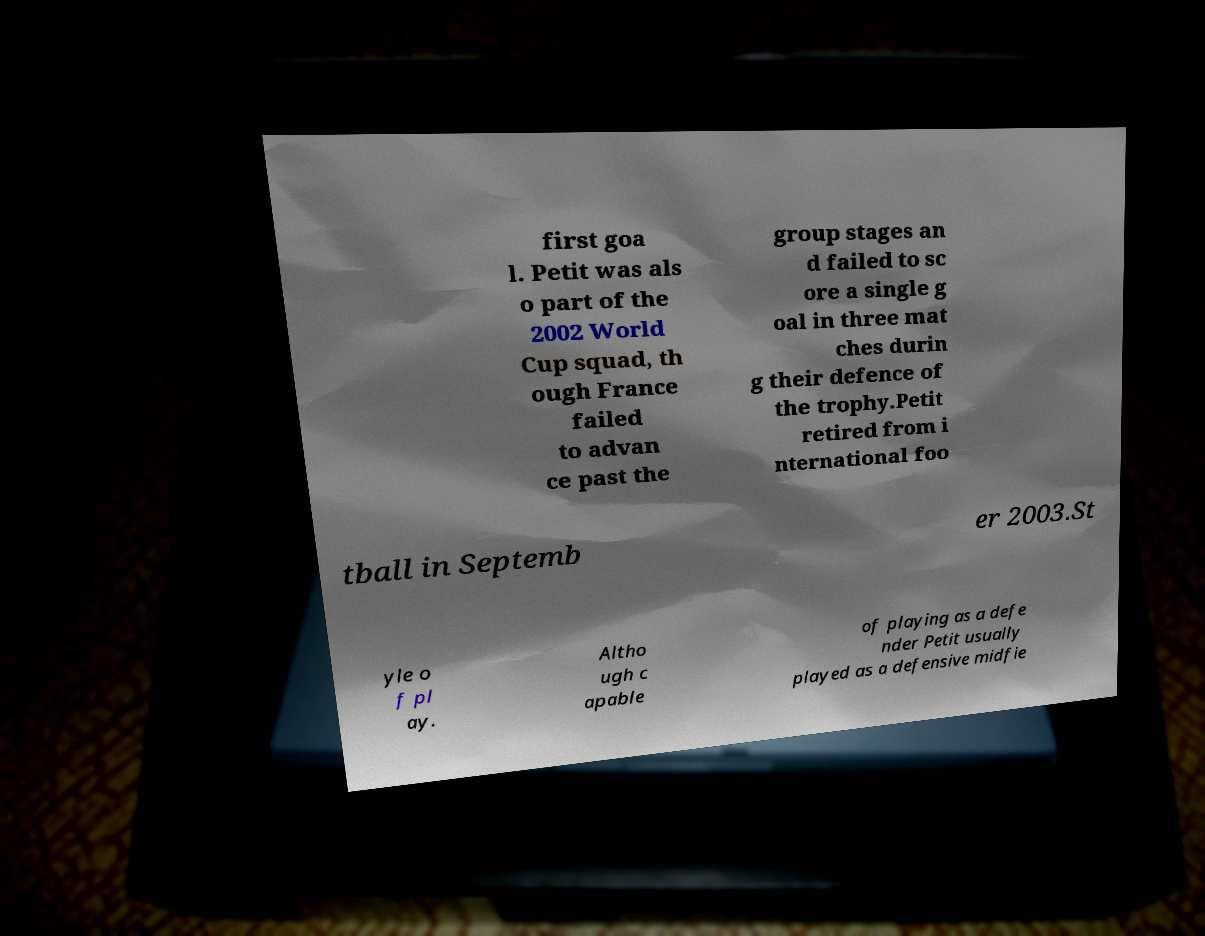Please identify and transcribe the text found in this image. first goa l. Petit was als o part of the 2002 World Cup squad, th ough France failed to advan ce past the group stages an d failed to sc ore a single g oal in three mat ches durin g their defence of the trophy.Petit retired from i nternational foo tball in Septemb er 2003.St yle o f pl ay. Altho ugh c apable of playing as a defe nder Petit usually played as a defensive midfie 